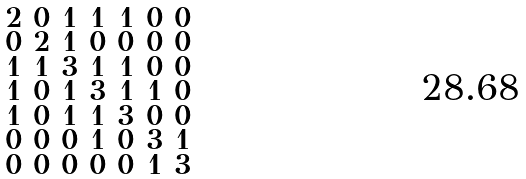Convert formula to latex. <formula><loc_0><loc_0><loc_500><loc_500>\begin{smallmatrix} 2 & 0 & 1 & 1 & 1 & 0 & 0 \\ 0 & 2 & 1 & 0 & 0 & 0 & 0 \\ 1 & 1 & 3 & 1 & 1 & 0 & 0 \\ 1 & 0 & 1 & 3 & 1 & 1 & 0 \\ 1 & 0 & 1 & 1 & 3 & 0 & 0 \\ 0 & 0 & 0 & 1 & 0 & 3 & 1 \\ 0 & 0 & 0 & 0 & 0 & 1 & 3 \end{smallmatrix}</formula> 